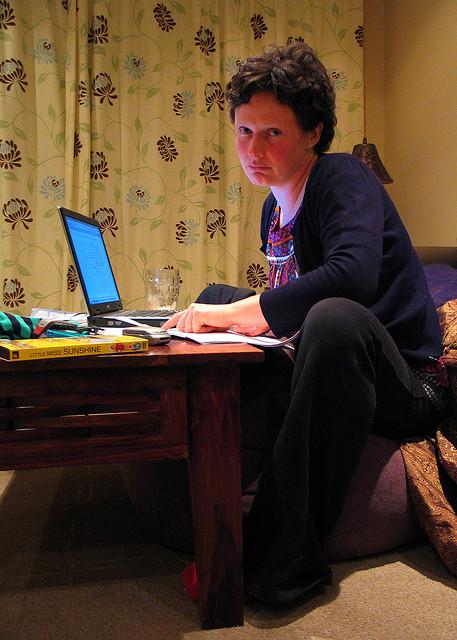What is on display on the laptop screen?
Give a very brief answer. Email. Is this woman smiling?
Keep it brief. No. Does this person look happy to have her picture taken?
Write a very short answer. No. 